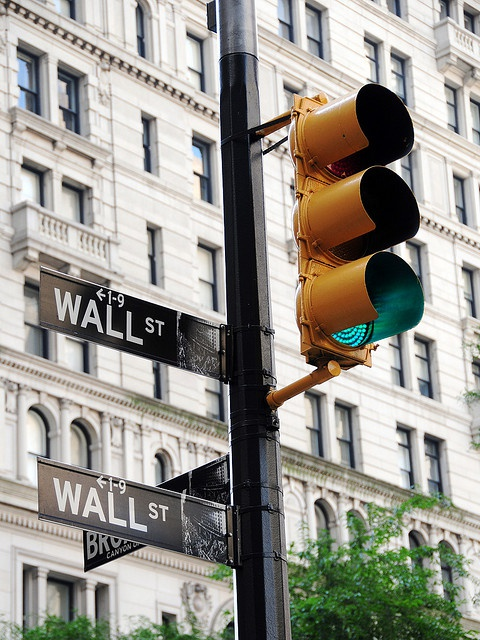Describe the objects in this image and their specific colors. I can see a traffic light in gray, black, brown, maroon, and teal tones in this image. 